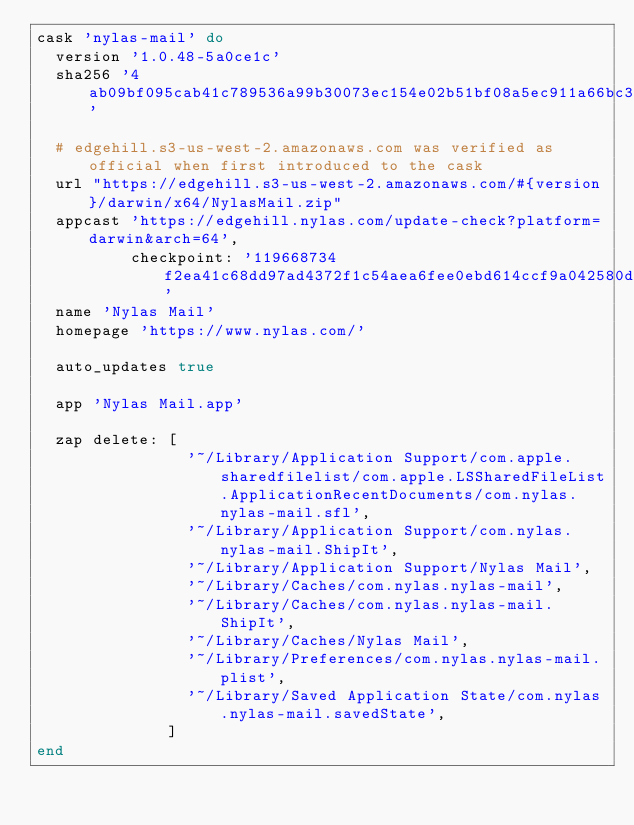Convert code to text. <code><loc_0><loc_0><loc_500><loc_500><_Ruby_>cask 'nylas-mail' do
  version '1.0.48-5a0ce1c'
  sha256 '4ab09bf095cab41c789536a99b30073ec154e02b51bf08a5ec911a66bc358f1c'

  # edgehill.s3-us-west-2.amazonaws.com was verified as official when first introduced to the cask
  url "https://edgehill.s3-us-west-2.amazonaws.com/#{version}/darwin/x64/NylasMail.zip"
  appcast 'https://edgehill.nylas.com/update-check?platform=darwin&arch=64',
          checkpoint: '119668734f2ea41c68dd97ad4372f1c54aea6fee0ebd614ccf9a042580d2ff1f'
  name 'Nylas Mail'
  homepage 'https://www.nylas.com/'

  auto_updates true

  app 'Nylas Mail.app'

  zap delete: [
                '~/Library/Application Support/com.apple.sharedfilelist/com.apple.LSSharedFileList.ApplicationRecentDocuments/com.nylas.nylas-mail.sfl',
                '~/Library/Application Support/com.nylas.nylas-mail.ShipIt',
                '~/Library/Application Support/Nylas Mail',
                '~/Library/Caches/com.nylas.nylas-mail',
                '~/Library/Caches/com.nylas.nylas-mail.ShipIt',
                '~/Library/Caches/Nylas Mail',
                '~/Library/Preferences/com.nylas.nylas-mail.plist',
                '~/Library/Saved Application State/com.nylas.nylas-mail.savedState',
              ]
end
</code> 